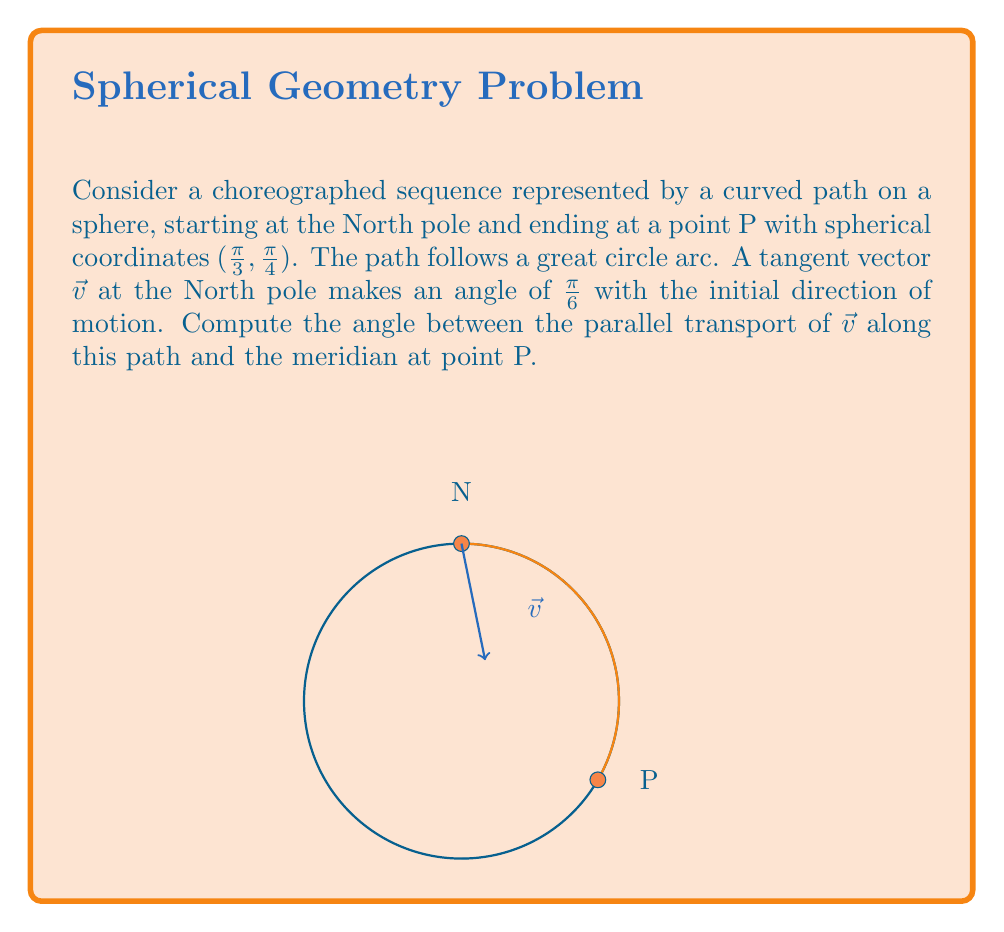Give your solution to this math problem. Let's approach this step-by-step:

1) First, we need to understand that parallel transport preserves the angle between the transported vector and the path. So, the angle between $\vec{v}$ and the path will remain $\frac{\pi}{6}$ throughout the transport.

2) The path follows a great circle arc. At the endpoint P, the tangent to this arc will be perpendicular to the radial vector OP.

3) The meridian at P is the great circle passing through P and the poles. Its tangent at P will be perpendicular to both OP and the east-west direction.

4) Let's define a local coordinate system at P:
   - $\hat{r}$: unit vector along OP
   - $\hat{\phi}$: unit vector in the east-west direction
   - $\hat{\theta}$: unit vector along the meridian (north-south)

5) The tangent to our path at P can be expressed as:
   $$\hat{t} = \cos(\frac{\pi}{4})\hat{\phi} - \sin(\frac{\pi}{4})\hat{\theta}$$

6) The parallel transported vector $\vec{v'}$ at P makes an angle of $\frac{\pi}{6}$ with $\hat{t}$. We can express it as:
   $$\vec{v'} = \cos(\frac{\pi}{6})\hat{t} + \sin(\frac{\pi}{6})\hat{r}$$

7) Substituting the expression for $\hat{t}$:
   $$\vec{v'} = \cos(\frac{\pi}{6})(\cos(\frac{\pi}{4})\hat{\phi} - \sin(\frac{\pi}{4})\hat{\theta}) + \sin(\frac{\pi}{6})\hat{r}$$

8) The component of $\vec{v'}$ in the $\hat{\theta}$ direction (along the meridian) is:
   $$-\cos(\frac{\pi}{6})\sin(\frac{\pi}{4})$$

9) The angle $\alpha$ between $\vec{v'}$ and the meridian is:
   $$\alpha = \arccos(-\cos(\frac{\pi}{6})\sin(\frac{\pi}{4}))$$

10) Calculating this:
    $$\alpha = \arccos(-\frac{\sqrt{3}}{2\sqrt{2}}) \approx 2.0344 \text{ radians}$$
Answer: $\arccos(-\frac{\sqrt{3}}{2\sqrt{2}})$ radians 